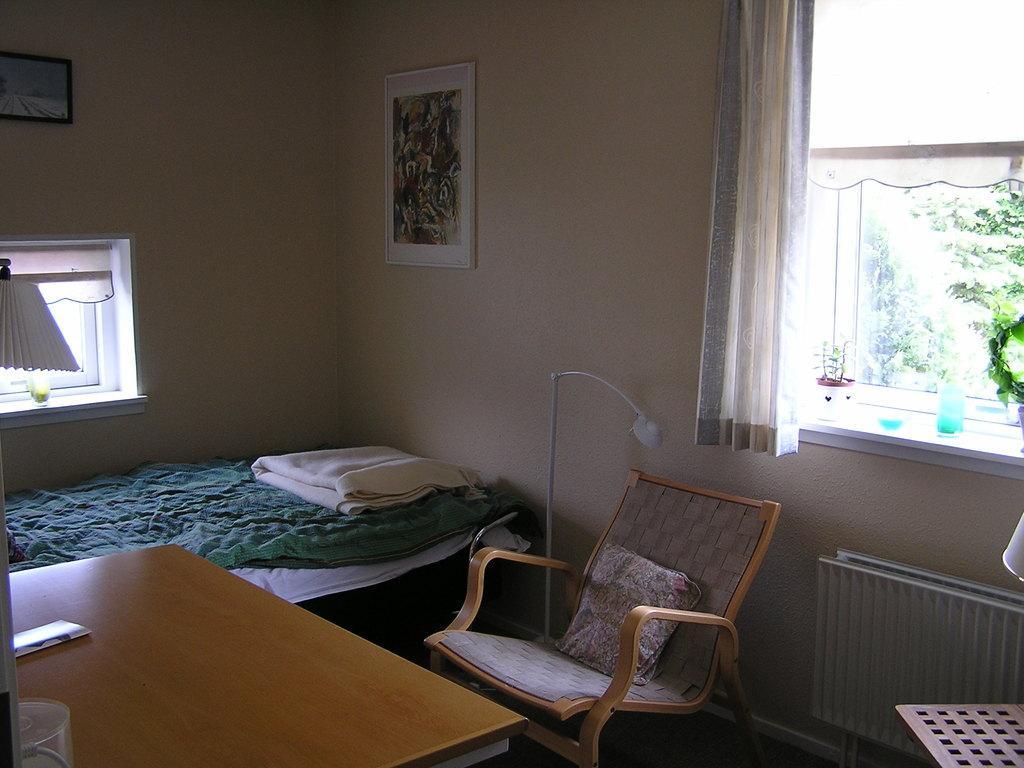In one or two sentences, can you explain what this image depicts? On the bottom there is a wooden chair near to the bed. On the bottom left corner we can see glass and paper on the table. On the right, through the window we can see trees and plants. Here we can see painting on the wall. On the top left corner there is a wall clock. 